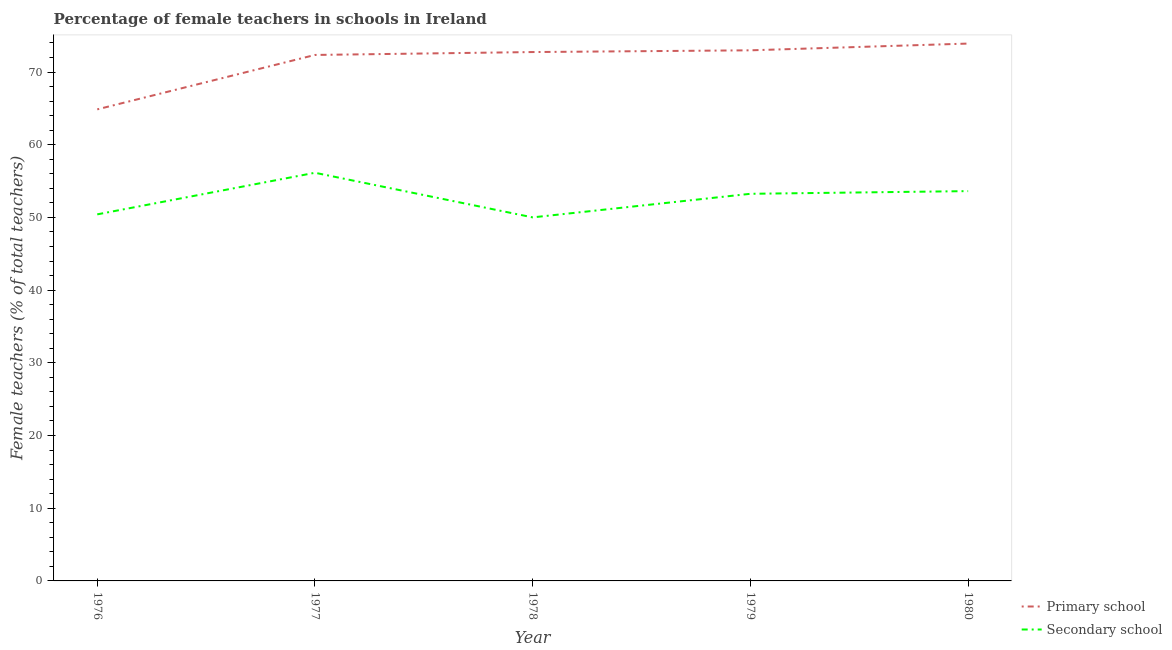Does the line corresponding to percentage of female teachers in primary schools intersect with the line corresponding to percentage of female teachers in secondary schools?
Your response must be concise. No. Is the number of lines equal to the number of legend labels?
Your response must be concise. Yes. What is the percentage of female teachers in secondary schools in 1980?
Offer a very short reply. 53.62. Across all years, what is the maximum percentage of female teachers in secondary schools?
Offer a very short reply. 56.15. Across all years, what is the minimum percentage of female teachers in primary schools?
Your answer should be compact. 64.87. In which year was the percentage of female teachers in primary schools maximum?
Make the answer very short. 1980. In which year was the percentage of female teachers in primary schools minimum?
Provide a succinct answer. 1976. What is the total percentage of female teachers in primary schools in the graph?
Your answer should be compact. 356.89. What is the difference between the percentage of female teachers in secondary schools in 1978 and that in 1980?
Your response must be concise. -3.61. What is the difference between the percentage of female teachers in secondary schools in 1977 and the percentage of female teachers in primary schools in 1980?
Your answer should be compact. -17.77. What is the average percentage of female teachers in secondary schools per year?
Your answer should be very brief. 52.69. In the year 1976, what is the difference between the percentage of female teachers in secondary schools and percentage of female teachers in primary schools?
Offer a terse response. -14.44. In how many years, is the percentage of female teachers in secondary schools greater than 6 %?
Offer a very short reply. 5. What is the ratio of the percentage of female teachers in secondary schools in 1978 to that in 1980?
Offer a very short reply. 0.93. What is the difference between the highest and the second highest percentage of female teachers in secondary schools?
Your answer should be very brief. 2.52. What is the difference between the highest and the lowest percentage of female teachers in primary schools?
Offer a very short reply. 9.05. In how many years, is the percentage of female teachers in secondary schools greater than the average percentage of female teachers in secondary schools taken over all years?
Make the answer very short. 3. Is the sum of the percentage of female teachers in secondary schools in 1979 and 1980 greater than the maximum percentage of female teachers in primary schools across all years?
Give a very brief answer. Yes. How many lines are there?
Provide a short and direct response. 2. How many years are there in the graph?
Give a very brief answer. 5. What is the difference between two consecutive major ticks on the Y-axis?
Your answer should be very brief. 10. Does the graph contain grids?
Give a very brief answer. No. Where does the legend appear in the graph?
Provide a succinct answer. Bottom right. How are the legend labels stacked?
Offer a terse response. Vertical. What is the title of the graph?
Keep it short and to the point. Percentage of female teachers in schools in Ireland. Does "Urban" appear as one of the legend labels in the graph?
Offer a terse response. No. What is the label or title of the X-axis?
Give a very brief answer. Year. What is the label or title of the Y-axis?
Your answer should be very brief. Female teachers (% of total teachers). What is the Female teachers (% of total teachers) in Primary school in 1976?
Provide a short and direct response. 64.87. What is the Female teachers (% of total teachers) in Secondary school in 1976?
Give a very brief answer. 50.43. What is the Female teachers (% of total teachers) of Primary school in 1977?
Ensure brevity in your answer.  72.35. What is the Female teachers (% of total teachers) of Secondary school in 1977?
Provide a succinct answer. 56.15. What is the Female teachers (% of total teachers) of Primary school in 1978?
Provide a succinct answer. 72.75. What is the Female teachers (% of total teachers) in Secondary school in 1978?
Your response must be concise. 50.01. What is the Female teachers (% of total teachers) in Primary school in 1979?
Your answer should be compact. 72.99. What is the Female teachers (% of total teachers) in Secondary school in 1979?
Make the answer very short. 53.25. What is the Female teachers (% of total teachers) of Primary school in 1980?
Offer a very short reply. 73.92. What is the Female teachers (% of total teachers) in Secondary school in 1980?
Your response must be concise. 53.62. Across all years, what is the maximum Female teachers (% of total teachers) of Primary school?
Your response must be concise. 73.92. Across all years, what is the maximum Female teachers (% of total teachers) of Secondary school?
Your answer should be compact. 56.15. Across all years, what is the minimum Female teachers (% of total teachers) of Primary school?
Your answer should be compact. 64.87. Across all years, what is the minimum Female teachers (% of total teachers) of Secondary school?
Keep it short and to the point. 50.01. What is the total Female teachers (% of total teachers) of Primary school in the graph?
Provide a succinct answer. 356.89. What is the total Female teachers (% of total teachers) in Secondary school in the graph?
Your response must be concise. 263.46. What is the difference between the Female teachers (% of total teachers) of Primary school in 1976 and that in 1977?
Offer a very short reply. -7.48. What is the difference between the Female teachers (% of total teachers) in Secondary school in 1976 and that in 1977?
Your answer should be very brief. -5.72. What is the difference between the Female teachers (% of total teachers) of Primary school in 1976 and that in 1978?
Your response must be concise. -7.88. What is the difference between the Female teachers (% of total teachers) of Secondary school in 1976 and that in 1978?
Offer a terse response. 0.42. What is the difference between the Female teachers (% of total teachers) in Primary school in 1976 and that in 1979?
Your answer should be compact. -8.12. What is the difference between the Female teachers (% of total teachers) of Secondary school in 1976 and that in 1979?
Provide a short and direct response. -2.83. What is the difference between the Female teachers (% of total teachers) of Primary school in 1976 and that in 1980?
Keep it short and to the point. -9.05. What is the difference between the Female teachers (% of total teachers) in Secondary school in 1976 and that in 1980?
Your response must be concise. -3.2. What is the difference between the Female teachers (% of total teachers) of Primary school in 1977 and that in 1978?
Ensure brevity in your answer.  -0.4. What is the difference between the Female teachers (% of total teachers) of Secondary school in 1977 and that in 1978?
Your response must be concise. 6.14. What is the difference between the Female teachers (% of total teachers) of Primary school in 1977 and that in 1979?
Your response must be concise. -0.64. What is the difference between the Female teachers (% of total teachers) of Secondary school in 1977 and that in 1979?
Ensure brevity in your answer.  2.89. What is the difference between the Female teachers (% of total teachers) of Primary school in 1977 and that in 1980?
Your answer should be very brief. -1.57. What is the difference between the Female teachers (% of total teachers) in Secondary school in 1977 and that in 1980?
Your answer should be very brief. 2.52. What is the difference between the Female teachers (% of total teachers) in Primary school in 1978 and that in 1979?
Give a very brief answer. -0.24. What is the difference between the Female teachers (% of total teachers) of Secondary school in 1978 and that in 1979?
Your answer should be compact. -3.24. What is the difference between the Female teachers (% of total teachers) in Primary school in 1978 and that in 1980?
Your response must be concise. -1.17. What is the difference between the Female teachers (% of total teachers) of Secondary school in 1978 and that in 1980?
Provide a succinct answer. -3.61. What is the difference between the Female teachers (% of total teachers) of Primary school in 1979 and that in 1980?
Give a very brief answer. -0.93. What is the difference between the Female teachers (% of total teachers) in Secondary school in 1979 and that in 1980?
Your answer should be compact. -0.37. What is the difference between the Female teachers (% of total teachers) of Primary school in 1976 and the Female teachers (% of total teachers) of Secondary school in 1977?
Give a very brief answer. 8.72. What is the difference between the Female teachers (% of total teachers) of Primary school in 1976 and the Female teachers (% of total teachers) of Secondary school in 1978?
Offer a very short reply. 14.86. What is the difference between the Female teachers (% of total teachers) of Primary school in 1976 and the Female teachers (% of total teachers) of Secondary school in 1979?
Offer a very short reply. 11.62. What is the difference between the Female teachers (% of total teachers) in Primary school in 1976 and the Female teachers (% of total teachers) in Secondary school in 1980?
Ensure brevity in your answer.  11.25. What is the difference between the Female teachers (% of total teachers) of Primary school in 1977 and the Female teachers (% of total teachers) of Secondary school in 1978?
Your answer should be very brief. 22.34. What is the difference between the Female teachers (% of total teachers) in Primary school in 1977 and the Female teachers (% of total teachers) in Secondary school in 1979?
Give a very brief answer. 19.1. What is the difference between the Female teachers (% of total teachers) in Primary school in 1977 and the Female teachers (% of total teachers) in Secondary school in 1980?
Provide a short and direct response. 18.73. What is the difference between the Female teachers (% of total teachers) of Primary school in 1978 and the Female teachers (% of total teachers) of Secondary school in 1979?
Offer a very short reply. 19.5. What is the difference between the Female teachers (% of total teachers) in Primary school in 1978 and the Female teachers (% of total teachers) in Secondary school in 1980?
Offer a terse response. 19.13. What is the difference between the Female teachers (% of total teachers) of Primary school in 1979 and the Female teachers (% of total teachers) of Secondary school in 1980?
Your response must be concise. 19.37. What is the average Female teachers (% of total teachers) in Primary school per year?
Provide a succinct answer. 71.38. What is the average Female teachers (% of total teachers) of Secondary school per year?
Ensure brevity in your answer.  52.69. In the year 1976, what is the difference between the Female teachers (% of total teachers) of Primary school and Female teachers (% of total teachers) of Secondary school?
Offer a very short reply. 14.44. In the year 1977, what is the difference between the Female teachers (% of total teachers) in Primary school and Female teachers (% of total teachers) in Secondary school?
Your response must be concise. 16.21. In the year 1978, what is the difference between the Female teachers (% of total teachers) in Primary school and Female teachers (% of total teachers) in Secondary school?
Keep it short and to the point. 22.74. In the year 1979, what is the difference between the Female teachers (% of total teachers) of Primary school and Female teachers (% of total teachers) of Secondary school?
Keep it short and to the point. 19.74. In the year 1980, what is the difference between the Female teachers (% of total teachers) in Primary school and Female teachers (% of total teachers) in Secondary school?
Keep it short and to the point. 20.3. What is the ratio of the Female teachers (% of total teachers) of Primary school in 1976 to that in 1977?
Your answer should be very brief. 0.9. What is the ratio of the Female teachers (% of total teachers) in Secondary school in 1976 to that in 1977?
Offer a very short reply. 0.9. What is the ratio of the Female teachers (% of total teachers) in Primary school in 1976 to that in 1978?
Make the answer very short. 0.89. What is the ratio of the Female teachers (% of total teachers) of Secondary school in 1976 to that in 1978?
Offer a very short reply. 1.01. What is the ratio of the Female teachers (% of total teachers) in Primary school in 1976 to that in 1979?
Provide a short and direct response. 0.89. What is the ratio of the Female teachers (% of total teachers) in Secondary school in 1976 to that in 1979?
Provide a succinct answer. 0.95. What is the ratio of the Female teachers (% of total teachers) of Primary school in 1976 to that in 1980?
Provide a succinct answer. 0.88. What is the ratio of the Female teachers (% of total teachers) in Secondary school in 1976 to that in 1980?
Provide a short and direct response. 0.94. What is the ratio of the Female teachers (% of total teachers) in Secondary school in 1977 to that in 1978?
Your answer should be very brief. 1.12. What is the ratio of the Female teachers (% of total teachers) of Secondary school in 1977 to that in 1979?
Offer a very short reply. 1.05. What is the ratio of the Female teachers (% of total teachers) in Primary school in 1977 to that in 1980?
Offer a terse response. 0.98. What is the ratio of the Female teachers (% of total teachers) in Secondary school in 1977 to that in 1980?
Offer a very short reply. 1.05. What is the ratio of the Female teachers (% of total teachers) in Primary school in 1978 to that in 1979?
Make the answer very short. 1. What is the ratio of the Female teachers (% of total teachers) in Secondary school in 1978 to that in 1979?
Your answer should be very brief. 0.94. What is the ratio of the Female teachers (% of total teachers) of Primary school in 1978 to that in 1980?
Provide a succinct answer. 0.98. What is the ratio of the Female teachers (% of total teachers) in Secondary school in 1978 to that in 1980?
Make the answer very short. 0.93. What is the ratio of the Female teachers (% of total teachers) of Primary school in 1979 to that in 1980?
Offer a terse response. 0.99. What is the ratio of the Female teachers (% of total teachers) of Secondary school in 1979 to that in 1980?
Keep it short and to the point. 0.99. What is the difference between the highest and the second highest Female teachers (% of total teachers) of Primary school?
Provide a succinct answer. 0.93. What is the difference between the highest and the second highest Female teachers (% of total teachers) in Secondary school?
Offer a very short reply. 2.52. What is the difference between the highest and the lowest Female teachers (% of total teachers) in Primary school?
Your response must be concise. 9.05. What is the difference between the highest and the lowest Female teachers (% of total teachers) in Secondary school?
Your response must be concise. 6.14. 